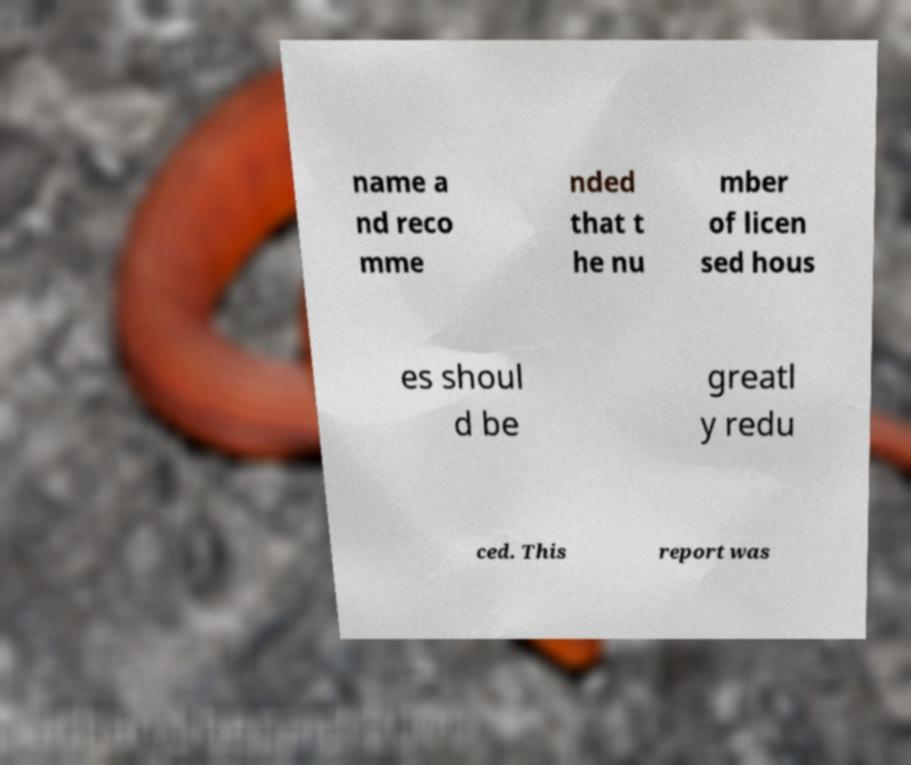Please identify and transcribe the text found in this image. name a nd reco mme nded that t he nu mber of licen sed hous es shoul d be greatl y redu ced. This report was 